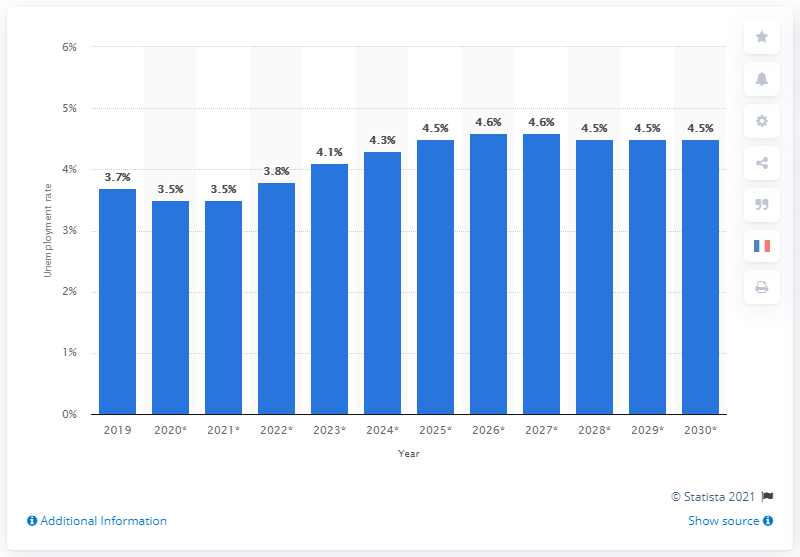Specify some key components in this picture. The unemployment rate in 2019 was 3.7%. According to projections, the unemployment rate in 2030 is expected to be 4.5%. 